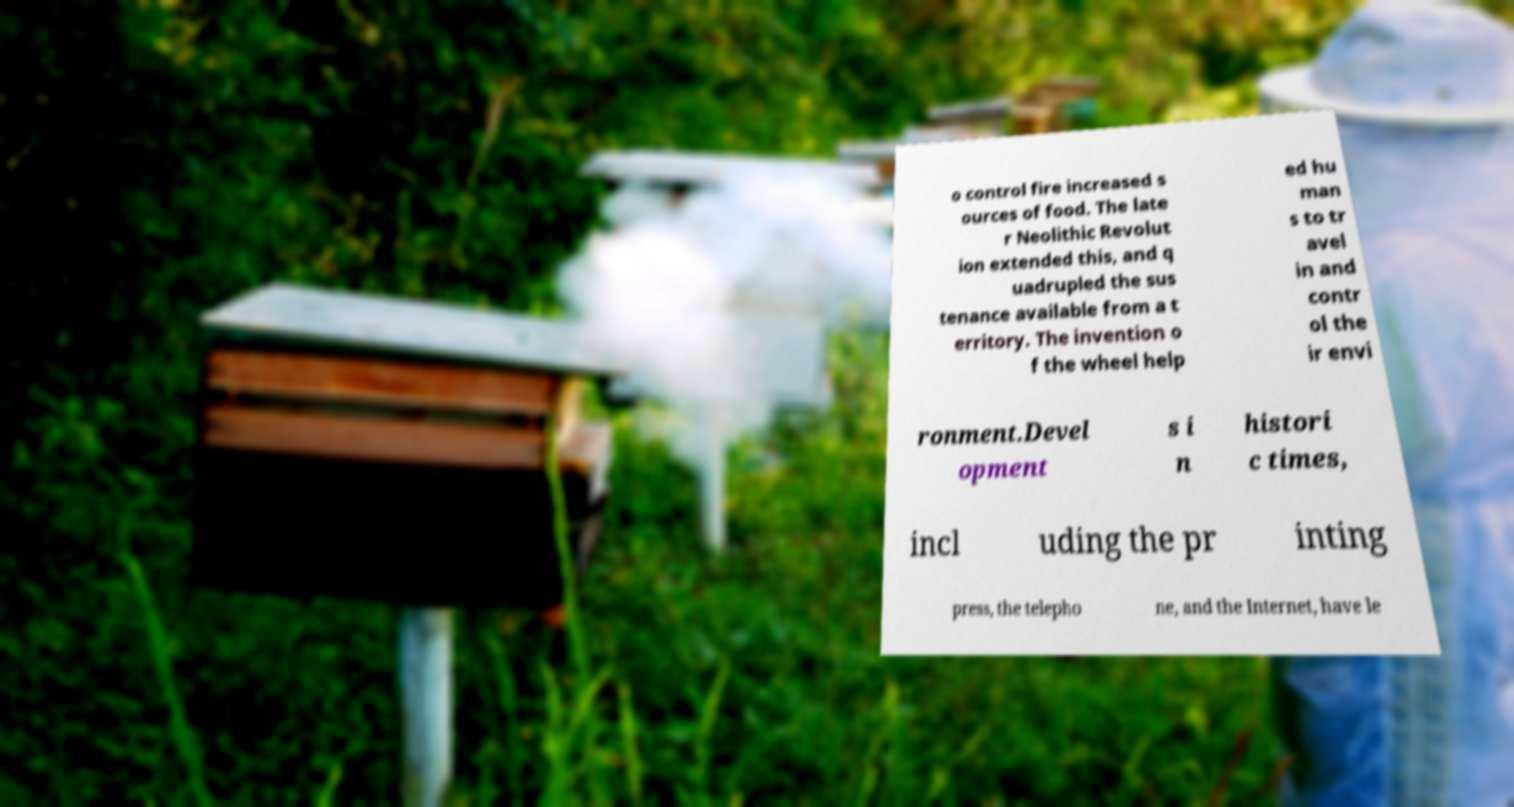Please identify and transcribe the text found in this image. o control fire increased s ources of food. The late r Neolithic Revolut ion extended this, and q uadrupled the sus tenance available from a t erritory. The invention o f the wheel help ed hu man s to tr avel in and contr ol the ir envi ronment.Devel opment s i n histori c times, incl uding the pr inting press, the telepho ne, and the Internet, have le 